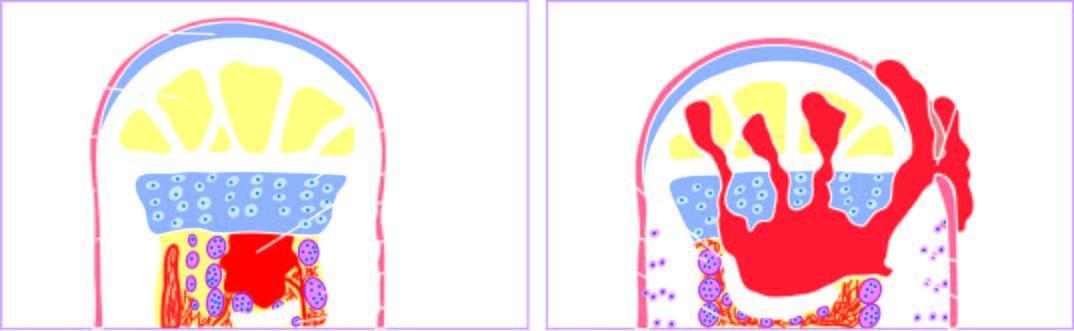do the alveolar walls expand further causing necrosis of the cortex called sequestrum?
Answer the question using a single word or phrase. No 